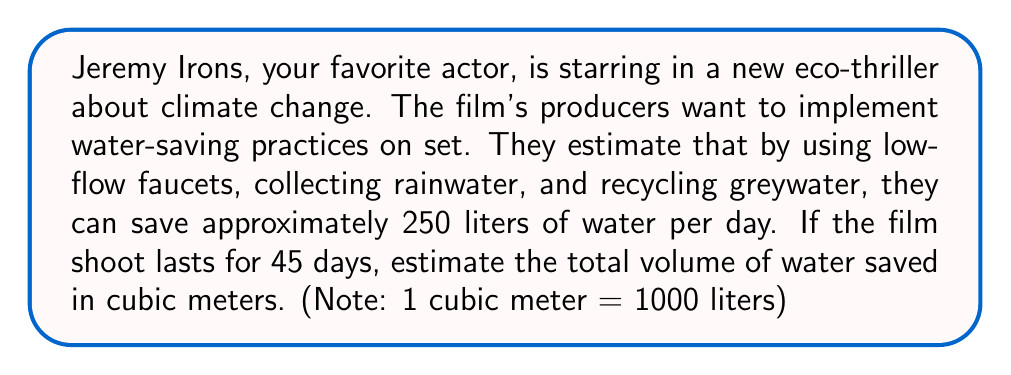Solve this math problem. To solve this problem, we need to follow these steps:

1. Calculate the total amount of water saved over the entire shoot:
   $$\text{Total liters saved} = \text{Liters saved per day} \times \text{Number of days}$$
   $$\text{Total liters saved} = 250 \text{ L/day} \times 45 \text{ days} = 11,250 \text{ L}$$

2. Convert liters to cubic meters:
   We know that 1 cubic meter = 1000 liters, so we can set up the following proportion:
   $$\frac{1 \text{ m}^3}{1000 \text{ L}} = \frac{x \text{ m}^3}{11,250 \text{ L}}$$

   Cross multiply and solve for $x$:
   $$1000x = 11,250$$
   $$x = \frac{11,250}{1000} = 11.25 \text{ m}^3$$

3. Round to a reasonable estimate:
   Since the question asks for an estimate, we can round 11.25 m³ to 11 m³.
Answer: The estimated volume of water saved is approximately 11 cubic meters. 